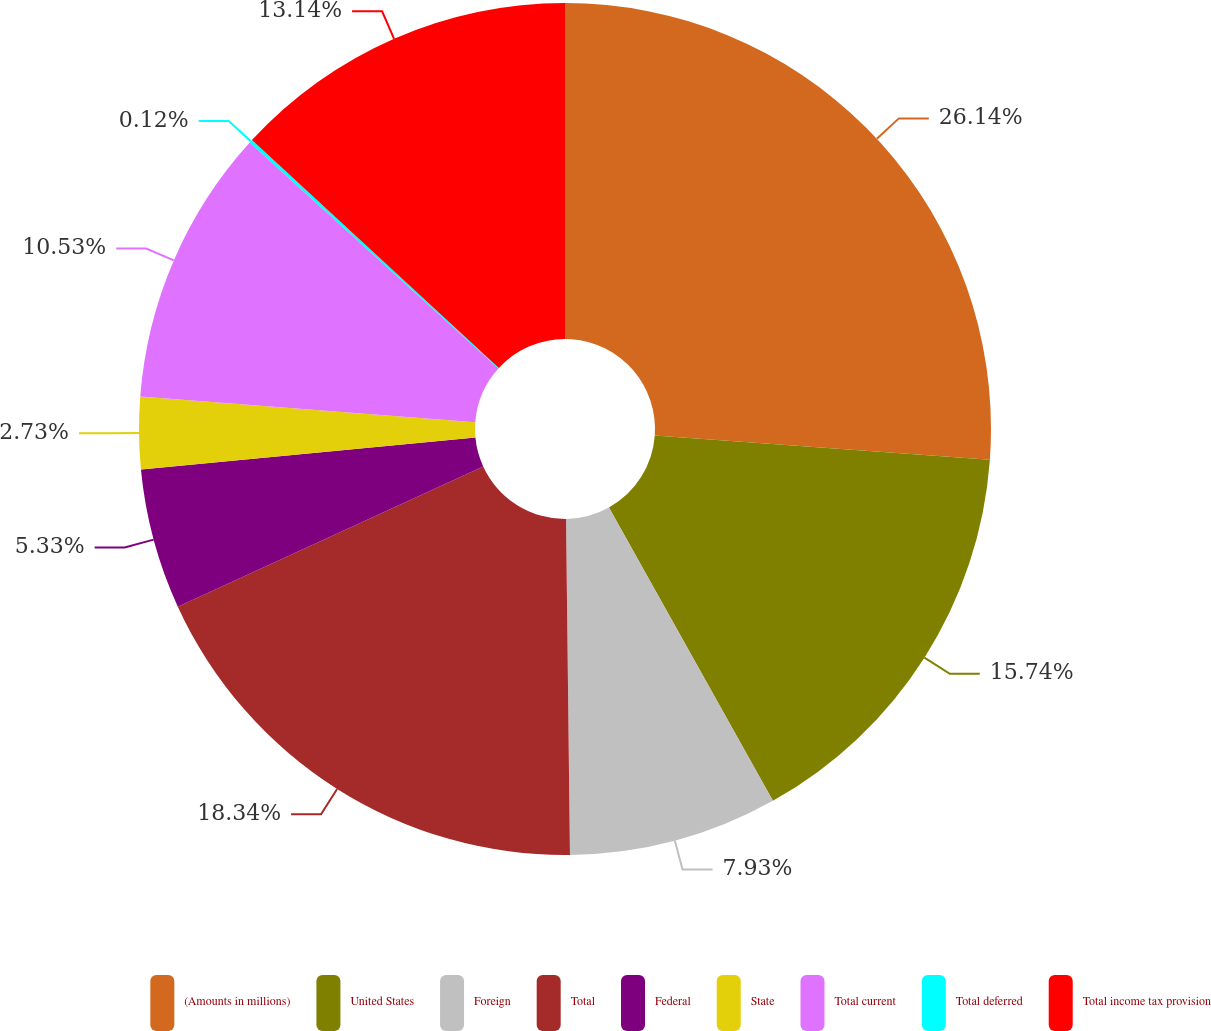Convert chart. <chart><loc_0><loc_0><loc_500><loc_500><pie_chart><fcel>(Amounts in millions)<fcel>United States<fcel>Foreign<fcel>Total<fcel>Federal<fcel>State<fcel>Total current<fcel>Total deferred<fcel>Total income tax provision<nl><fcel>26.15%<fcel>15.74%<fcel>7.93%<fcel>18.34%<fcel>5.33%<fcel>2.73%<fcel>10.53%<fcel>0.12%<fcel>13.14%<nl></chart> 